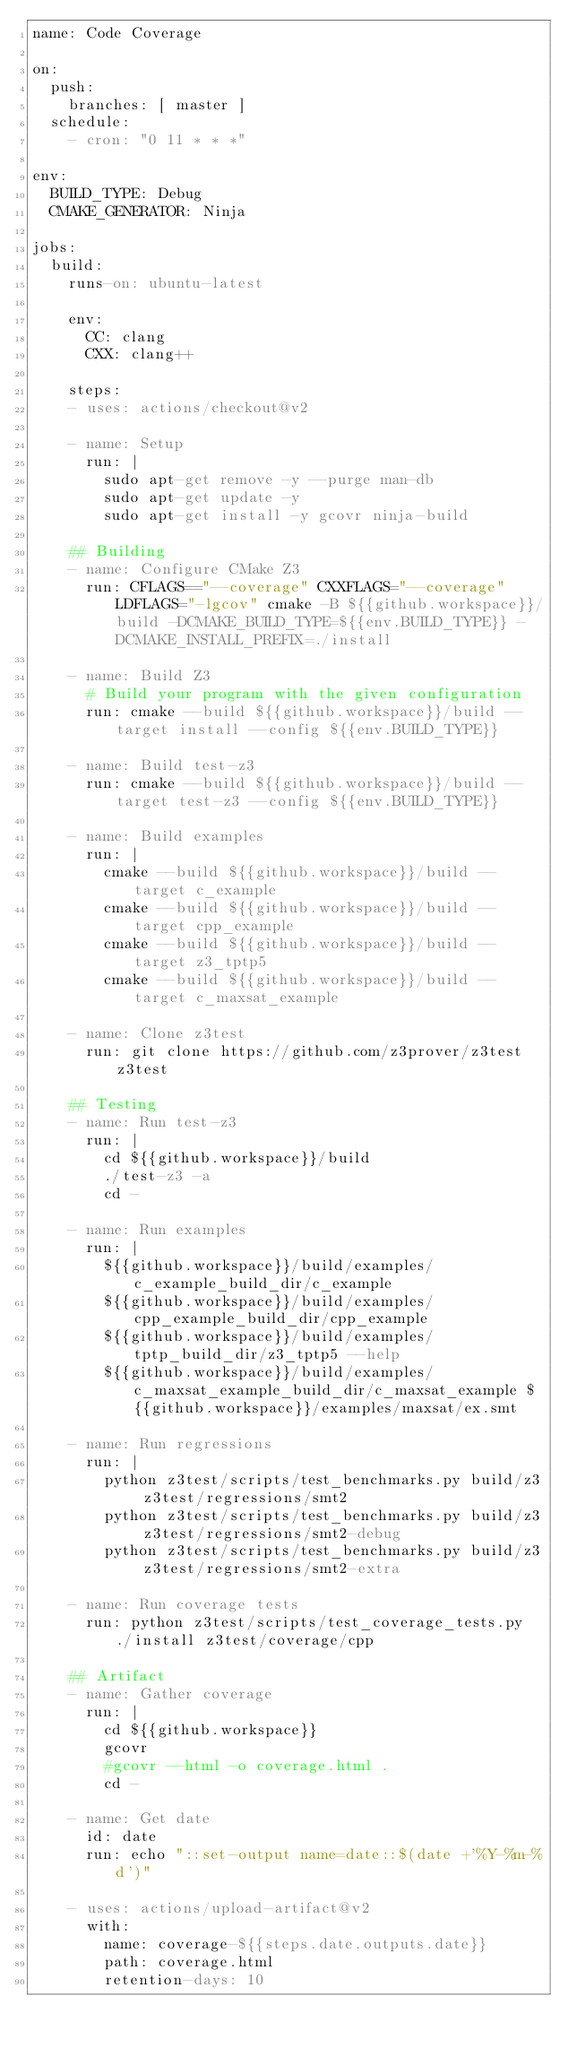<code> <loc_0><loc_0><loc_500><loc_500><_YAML_>name: Code Coverage

on:
  push:
    branches: [ master ]
  schedule:
    - cron: "0 11 * * *"

env:
  BUILD_TYPE: Debug
  CMAKE_GENERATOR: Ninja

jobs:
  build:
    runs-on: ubuntu-latest

    env:
      CC: clang
      CXX: clang++

    steps:
    - uses: actions/checkout@v2

    - name: Setup
      run: |
        sudo apt-get remove -y --purge man-db
        sudo apt-get update -y
        sudo apt-get install -y gcovr ninja-build

    ## Building
    - name: Configure CMake Z3
      run: CFLAGS=="--coverage" CXXFLAGS="--coverage" LDFLAGS="-lgcov" cmake -B ${{github.workspace}}/build -DCMAKE_BUILD_TYPE=${{env.BUILD_TYPE}} -DCMAKE_INSTALL_PREFIX=./install

    - name: Build Z3
      # Build your program with the given configuration
      run: cmake --build ${{github.workspace}}/build --target install --config ${{env.BUILD_TYPE}}

    - name: Build test-z3
      run: cmake --build ${{github.workspace}}/build --target test-z3 --config ${{env.BUILD_TYPE}}

    - name: Build examples
      run: |
        cmake --build ${{github.workspace}}/build --target c_example
        cmake --build ${{github.workspace}}/build --target cpp_example
        cmake --build ${{github.workspace}}/build --target z3_tptp5
        cmake --build ${{github.workspace}}/build --target c_maxsat_example

    - name: Clone z3test
      run: git clone https://github.com/z3prover/z3test z3test

    ## Testing
    - name: Run test-z3
      run: |
        cd ${{github.workspace}}/build
        ./test-z3 -a
        cd -

    - name: Run examples
      run: |
        ${{github.workspace}}/build/examples/c_example_build_dir/c_example
        ${{github.workspace}}/build/examples/cpp_example_build_dir/cpp_example
        ${{github.workspace}}/build/examples/tptp_build_dir/z3_tptp5 --help
        ${{github.workspace}}/build/examples/c_maxsat_example_build_dir/c_maxsat_example ${{github.workspace}}/examples/maxsat/ex.smt

    - name: Run regressions
      run: |
        python z3test/scripts/test_benchmarks.py build/z3 z3test/regressions/smt2
        python z3test/scripts/test_benchmarks.py build/z3 z3test/regressions/smt2-debug
        python z3test/scripts/test_benchmarks.py build/z3 z3test/regressions/smt2-extra

    - name: Run coverage tests
      run: python z3test/scripts/test_coverage_tests.py ./install z3test/coverage/cpp

    ## Artifact
    - name: Gather coverage
      run: |
        cd ${{github.workspace}}
        gcovr
        #gcovr --html -o coverage.html .
        cd -

    - name: Get date
      id: date
      run: echo "::set-output name=date::$(date +'%Y-%m-%d')"

    - uses: actions/upload-artifact@v2
      with:
        name: coverage-${{steps.date.outputs.date}}
        path: coverage.html
        retention-days: 10
</code> 